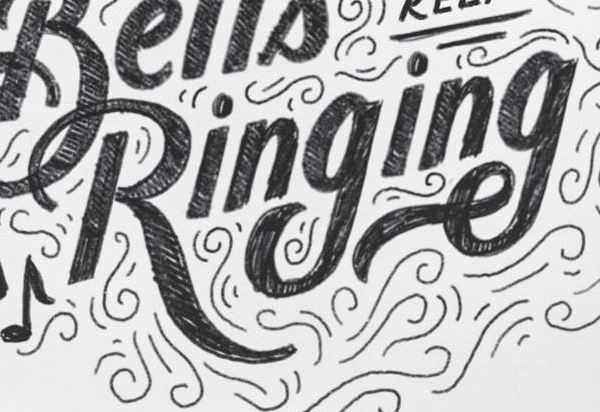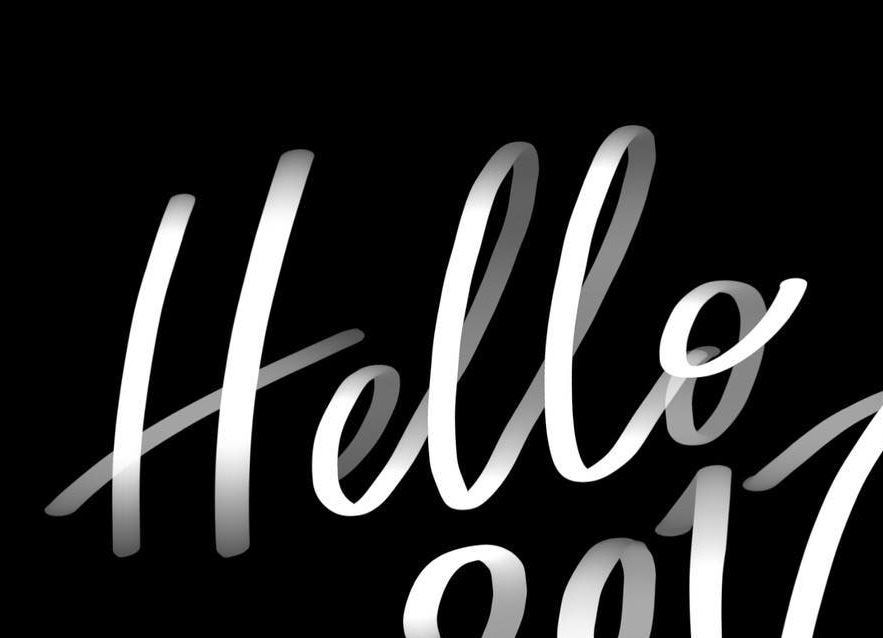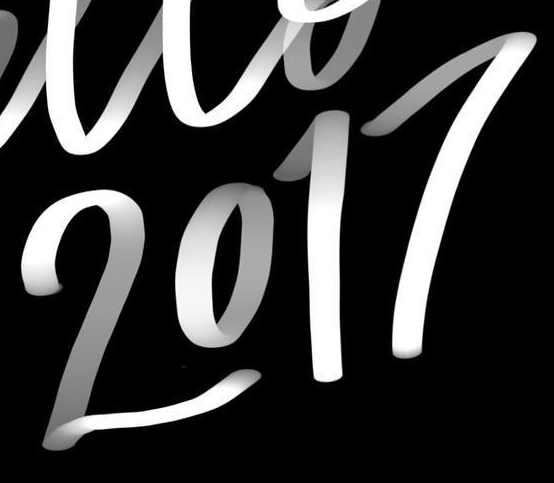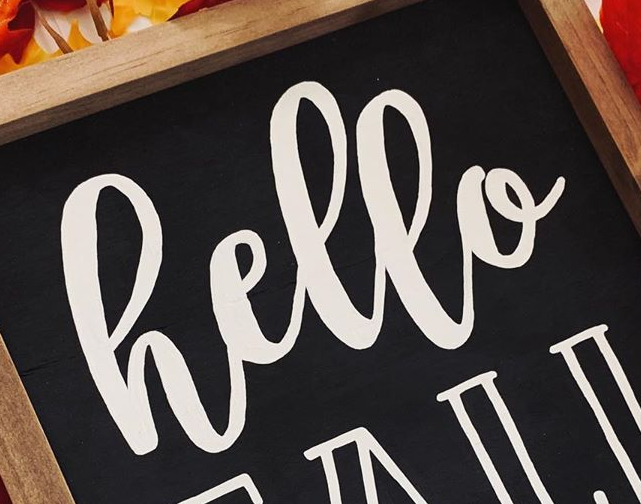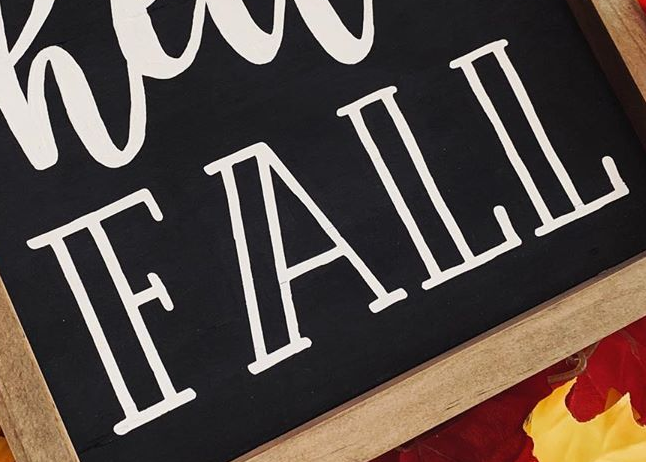What text is displayed in these images sequentially, separated by a semicolon? Ringing; Hello; 2017; hello; FALL 